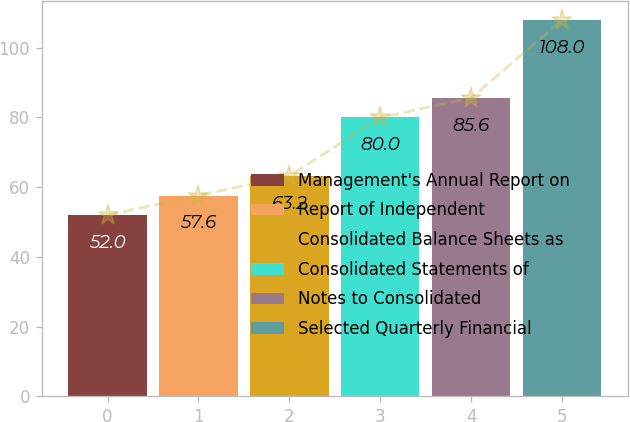<chart> <loc_0><loc_0><loc_500><loc_500><bar_chart><fcel>Management's Annual Report on<fcel>Report of Independent<fcel>Consolidated Balance Sheets as<fcel>Consolidated Statements of<fcel>Notes to Consolidated<fcel>Selected Quarterly Financial<nl><fcel>52<fcel>57.6<fcel>63.2<fcel>80<fcel>85.6<fcel>108<nl></chart> 